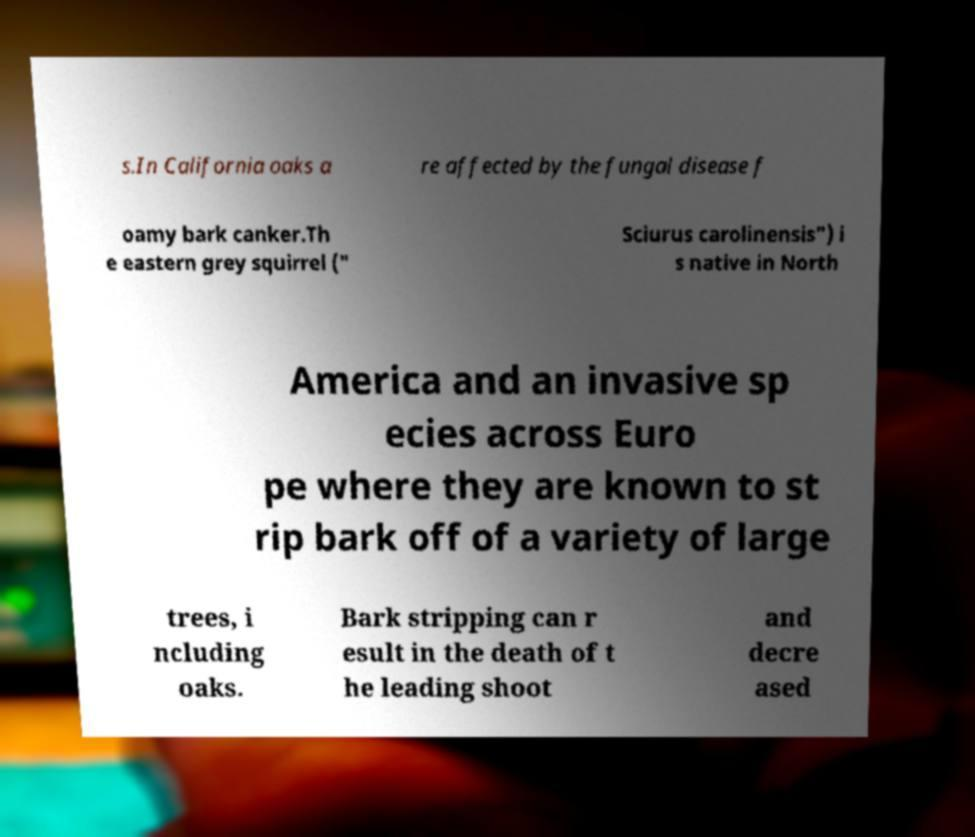Can you accurately transcribe the text from the provided image for me? s.In California oaks a re affected by the fungal disease f oamy bark canker.Th e eastern grey squirrel (" Sciurus carolinensis") i s native in North America and an invasive sp ecies across Euro pe where they are known to st rip bark off of a variety of large trees, i ncluding oaks. Bark stripping can r esult in the death of t he leading shoot and decre ased 